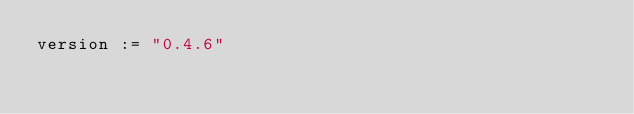<code> <loc_0><loc_0><loc_500><loc_500><_Scala_>version := "0.4.6"
</code> 